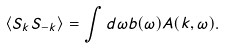Convert formula to latex. <formula><loc_0><loc_0><loc_500><loc_500>\langle S _ { k } S _ { - k } \rangle = \int d \omega b ( { \omega } ) A ( { k } , \omega ) .</formula> 